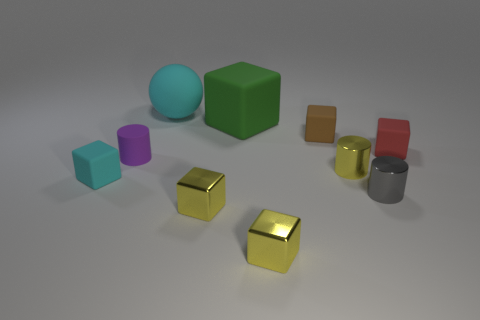How many objects are red matte cubes or cylinders on the right side of the brown thing?
Offer a terse response. 3. There is a purple thing that is the same size as the brown cube; what is its material?
Offer a terse response. Rubber. What material is the small cylinder that is behind the small cyan cube and right of the big cyan matte sphere?
Provide a succinct answer. Metal. There is a tiny yellow block to the left of the large green thing; are there any large things that are to the left of it?
Offer a very short reply. Yes. There is a rubber thing that is both in front of the red rubber object and right of the tiny cyan object; what is its size?
Your response must be concise. Small. What number of yellow objects are tiny cylinders or shiny balls?
Offer a very short reply. 1. There is a red object that is the same size as the brown object; what is its shape?
Offer a terse response. Cube. How many other objects are the same color as the big rubber sphere?
Keep it short and to the point. 1. There is a green matte block behind the small matte block that is in front of the purple matte cylinder; what size is it?
Keep it short and to the point. Large. Does the cyan object in front of the purple rubber thing have the same material as the cyan ball?
Provide a short and direct response. Yes. 